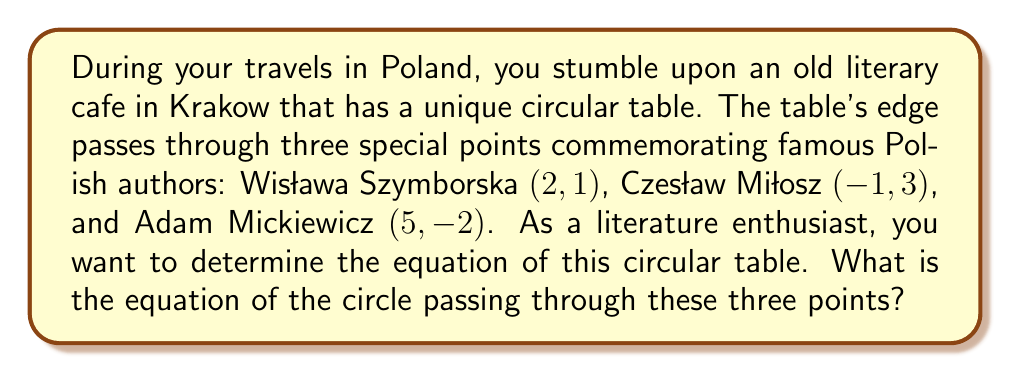Give your solution to this math problem. To find the equation of a circle passing through three given points, we can follow these steps:

1) The general equation of a circle is $$(x-h)^2 + (y-k)^2 = r^2$$
   where $(h,k)$ is the center and $r$ is the radius.

2) We can use the expanded form: $$x^2 + y^2 + Dx + Ey + F = 0$$
   where $D = -2h$, $E = -2k$, and $F = h^2 + k^2 - r^2$

3) Substitute the three given points into this equation:
   For (2, 1):   $2^2 + 1^2 + 2D + E + F = 0$
   For (-1, 3):  $(-1)^2 + 3^2 + (-1)D + 3E + F = 0$
   For (5, -2):  $5^2 + (-2)^2 + 5D + (-2)E + F = 0$

4) This gives us a system of three equations:
   $$5 + 2D + E + F = 0$$
   $$10 - D + 3E + F = 0$$
   $$29 + 5D - 2E + F = 0$$

5) Subtracting the first equation from the second:
   $$5 - 3D + 2E = 0$$

6) Subtracting the first equation from the third:
   $$24 + 3D - 3E = 0$$

7) Adding these last two equations:
   $$29 = 0$$
   This is always true, confirming that a circle does pass through these points.

8) From step 5: $E = \frac{3D-5}{2}$

9) Substitute this into the equation from step 6:
   $$24 + 3D - 3(\frac{3D-5}{2}) = 0$$
   $$48 + 6D - 9D + 15 = 0$$
   $$63 - 3D = 0$$
   $$D = 21$$

10) Therefore, $E = \frac{3(21)-5}{2} = \frac{58}{2} = 29$

11) Substitute D and E into the first equation from step 4:
    $$5 + 2(21) + 29 + F = 0$$
    $$F = -76$$

12) Now we have D, E, and F. Recall that $D = -2h$ and $E = -2k$:
    $h = -\frac{D}{2} = -\frac{21}{2}$
    $k = -\frac{E}{2} = -\frac{29}{2}$

13) The equation of the circle is therefore:
    $$(x+\frac{21}{2})^2 + (y+\frac{29}{2})^2 = (\frac{21}{2})^2 + (\frac{29}{2})^2 - (-76) = \frac{3746}{4}$$
Answer: The equation of the circle is $$(x+\frac{21}{2})^2 + (y+\frac{29}{2})^2 = \frac{3746}{4}$$ 